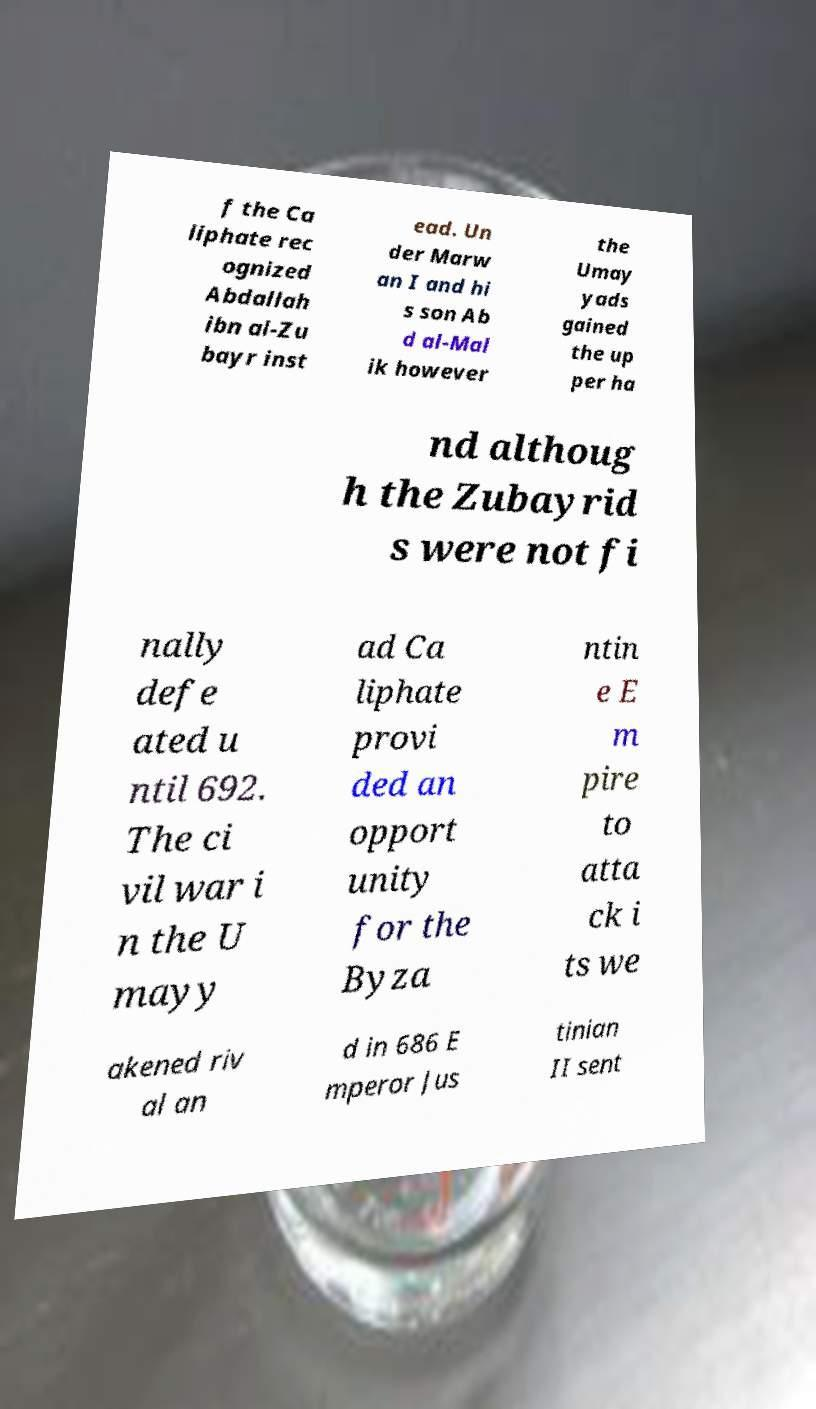Please read and relay the text visible in this image. What does it say? f the Ca liphate rec ognized Abdallah ibn al-Zu bayr inst ead. Un der Marw an I and hi s son Ab d al-Mal ik however the Umay yads gained the up per ha nd althoug h the Zubayrid s were not fi nally defe ated u ntil 692. The ci vil war i n the U mayy ad Ca liphate provi ded an opport unity for the Byza ntin e E m pire to atta ck i ts we akened riv al an d in 686 E mperor Jus tinian II sent 